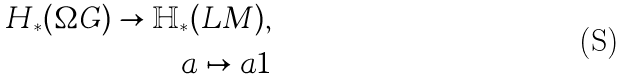Convert formula to latex. <formula><loc_0><loc_0><loc_500><loc_500>H _ { \ast } ( \Omega G ) \to \mathbb { H } _ { \ast } ( L M ) , \\ a \mapsto a 1</formula> 